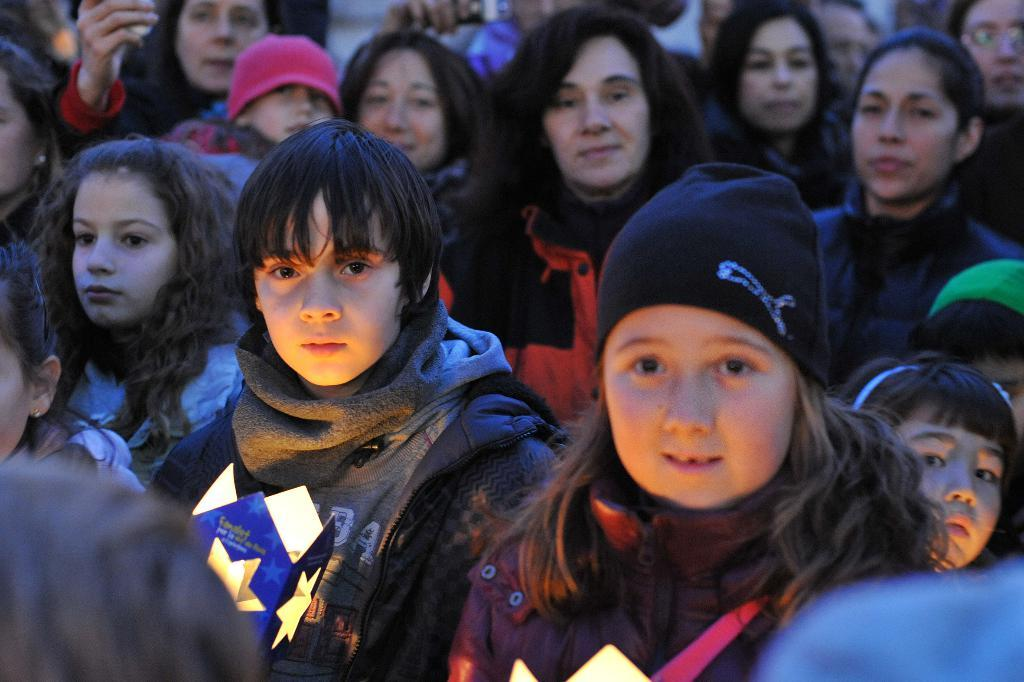What is the main subject of the image? The main subject of the image is a group of women. Can you describe the girls in the middle of the group? Two girls are holding boxes in the middle of the group. What accessories are the girls wearing? The girls are wearing scarves and caps. How many apples are on the cap of the girl on the left? There are no apples present on the cap of the girl on the left, as the provided facts do not mention any apples. 